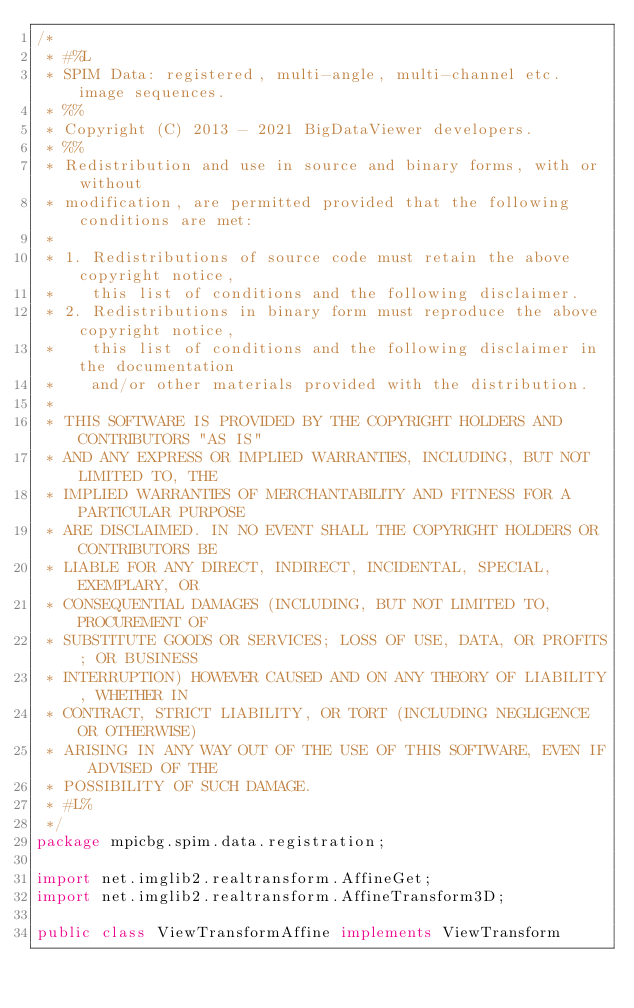<code> <loc_0><loc_0><loc_500><loc_500><_Java_>/*
 * #%L
 * SPIM Data: registered, multi-angle, multi-channel etc. image sequences.
 * %%
 * Copyright (C) 2013 - 2021 BigDataViewer developers.
 * %%
 * Redistribution and use in source and binary forms, with or without
 * modification, are permitted provided that the following conditions are met:
 * 
 * 1. Redistributions of source code must retain the above copyright notice,
 *    this list of conditions and the following disclaimer.
 * 2. Redistributions in binary form must reproduce the above copyright notice,
 *    this list of conditions and the following disclaimer in the documentation
 *    and/or other materials provided with the distribution.
 * 
 * THIS SOFTWARE IS PROVIDED BY THE COPYRIGHT HOLDERS AND CONTRIBUTORS "AS IS"
 * AND ANY EXPRESS OR IMPLIED WARRANTIES, INCLUDING, BUT NOT LIMITED TO, THE
 * IMPLIED WARRANTIES OF MERCHANTABILITY AND FITNESS FOR A PARTICULAR PURPOSE
 * ARE DISCLAIMED. IN NO EVENT SHALL THE COPYRIGHT HOLDERS OR CONTRIBUTORS BE
 * LIABLE FOR ANY DIRECT, INDIRECT, INCIDENTAL, SPECIAL, EXEMPLARY, OR
 * CONSEQUENTIAL DAMAGES (INCLUDING, BUT NOT LIMITED TO, PROCUREMENT OF
 * SUBSTITUTE GOODS OR SERVICES; LOSS OF USE, DATA, OR PROFITS; OR BUSINESS
 * INTERRUPTION) HOWEVER CAUSED AND ON ANY THEORY OF LIABILITY, WHETHER IN
 * CONTRACT, STRICT LIABILITY, OR TORT (INCLUDING NEGLIGENCE OR OTHERWISE)
 * ARISING IN ANY WAY OUT OF THE USE OF THIS SOFTWARE, EVEN IF ADVISED OF THE
 * POSSIBILITY OF SUCH DAMAGE.
 * #L%
 */
package mpicbg.spim.data.registration;

import net.imglib2.realtransform.AffineGet;
import net.imglib2.realtransform.AffineTransform3D;

public class ViewTransformAffine implements ViewTransform</code> 